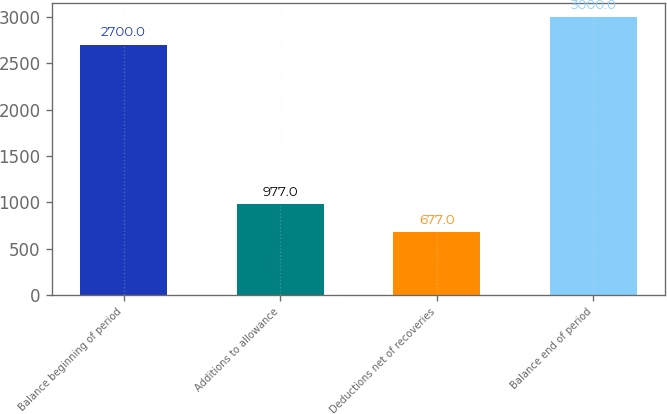Convert chart to OTSL. <chart><loc_0><loc_0><loc_500><loc_500><bar_chart><fcel>Balance beginning of period<fcel>Additions to allowance<fcel>Deductions net of recoveries<fcel>Balance end of period<nl><fcel>2700<fcel>977<fcel>677<fcel>3000<nl></chart> 